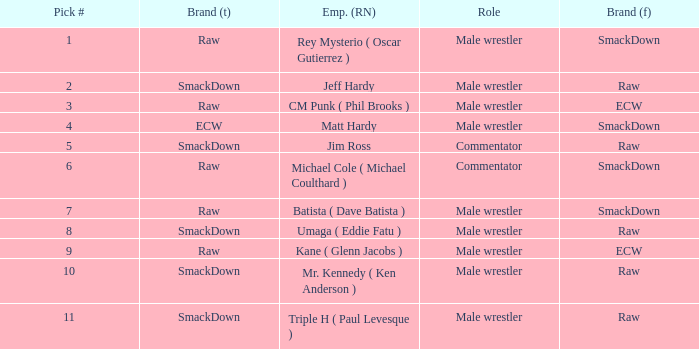What is the real name of the male wrestler from Raw with a pick # smaller than 6? Jeff Hardy. 